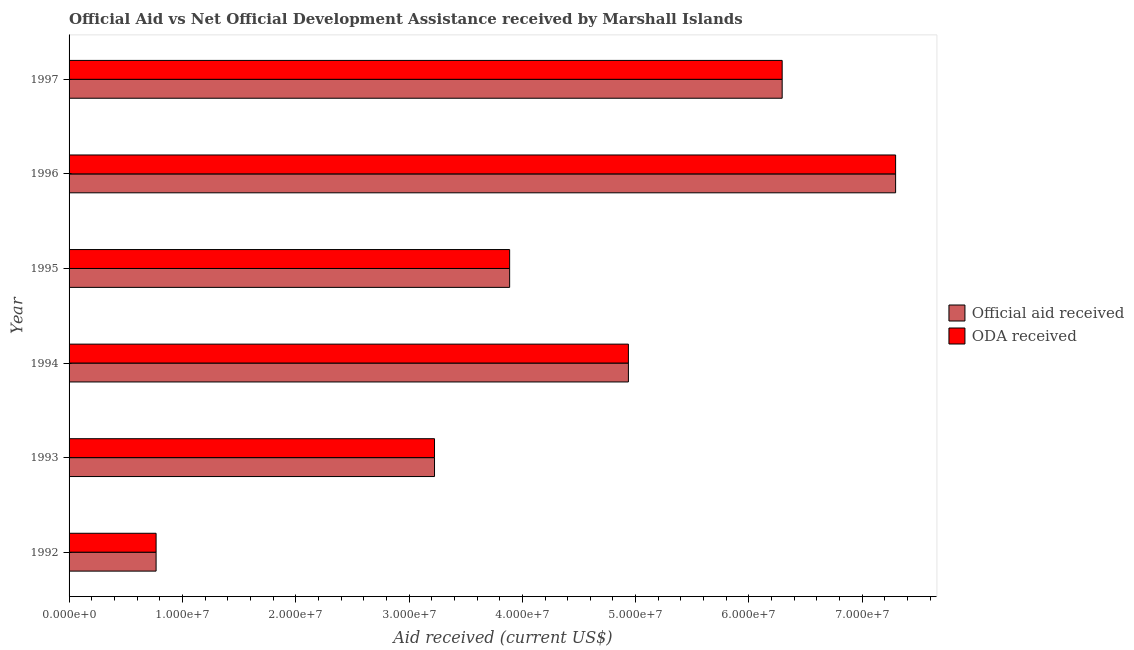How many different coloured bars are there?
Make the answer very short. 2. Are the number of bars per tick equal to the number of legend labels?
Make the answer very short. Yes. Are the number of bars on each tick of the Y-axis equal?
Offer a very short reply. Yes. How many bars are there on the 5th tick from the top?
Give a very brief answer. 2. How many bars are there on the 4th tick from the bottom?
Provide a short and direct response. 2. What is the oda received in 1997?
Ensure brevity in your answer.  6.29e+07. Across all years, what is the maximum official aid received?
Your answer should be very brief. 7.29e+07. Across all years, what is the minimum oda received?
Your answer should be compact. 7.68e+06. In which year was the official aid received maximum?
Your answer should be compact. 1996. In which year was the official aid received minimum?
Give a very brief answer. 1992. What is the total oda received in the graph?
Your answer should be very brief. 2.64e+08. What is the difference between the oda received in 1993 and that in 1994?
Offer a terse response. -1.71e+07. What is the difference between the oda received in 1995 and the official aid received in 1994?
Keep it short and to the point. -1.05e+07. What is the average official aid received per year?
Give a very brief answer. 4.40e+07. In the year 1996, what is the difference between the official aid received and oda received?
Your answer should be very brief. 0. What is the ratio of the oda received in 1992 to that in 1994?
Offer a terse response. 0.16. Is the difference between the oda received in 1992 and 1996 greater than the difference between the official aid received in 1992 and 1996?
Provide a short and direct response. No. What is the difference between the highest and the second highest official aid received?
Offer a very short reply. 1.00e+07. What is the difference between the highest and the lowest official aid received?
Provide a succinct answer. 6.53e+07. Is the sum of the official aid received in 1992 and 1995 greater than the maximum oda received across all years?
Offer a very short reply. No. What does the 1st bar from the top in 1995 represents?
Your answer should be compact. ODA received. What does the 1st bar from the bottom in 1995 represents?
Give a very brief answer. Official aid received. What is the difference between two consecutive major ticks on the X-axis?
Your response must be concise. 1.00e+07. Are the values on the major ticks of X-axis written in scientific E-notation?
Your answer should be compact. Yes. Does the graph contain grids?
Ensure brevity in your answer.  No. Where does the legend appear in the graph?
Offer a terse response. Center right. How are the legend labels stacked?
Keep it short and to the point. Vertical. What is the title of the graph?
Offer a very short reply. Official Aid vs Net Official Development Assistance received by Marshall Islands . Does "RDB nonconcessional" appear as one of the legend labels in the graph?
Provide a short and direct response. No. What is the label or title of the X-axis?
Your response must be concise. Aid received (current US$). What is the Aid received (current US$) in Official aid received in 1992?
Your answer should be compact. 7.68e+06. What is the Aid received (current US$) in ODA received in 1992?
Give a very brief answer. 7.68e+06. What is the Aid received (current US$) of Official aid received in 1993?
Offer a very short reply. 3.22e+07. What is the Aid received (current US$) of ODA received in 1993?
Offer a very short reply. 3.22e+07. What is the Aid received (current US$) in Official aid received in 1994?
Your response must be concise. 4.94e+07. What is the Aid received (current US$) in ODA received in 1994?
Your response must be concise. 4.94e+07. What is the Aid received (current US$) in Official aid received in 1995?
Give a very brief answer. 3.89e+07. What is the Aid received (current US$) of ODA received in 1995?
Provide a short and direct response. 3.89e+07. What is the Aid received (current US$) of Official aid received in 1996?
Your answer should be compact. 7.29e+07. What is the Aid received (current US$) of ODA received in 1996?
Your answer should be very brief. 7.29e+07. What is the Aid received (current US$) of Official aid received in 1997?
Provide a succinct answer. 6.29e+07. What is the Aid received (current US$) of ODA received in 1997?
Your answer should be very brief. 6.29e+07. Across all years, what is the maximum Aid received (current US$) of Official aid received?
Your answer should be compact. 7.29e+07. Across all years, what is the maximum Aid received (current US$) of ODA received?
Offer a terse response. 7.29e+07. Across all years, what is the minimum Aid received (current US$) in Official aid received?
Give a very brief answer. 7.68e+06. Across all years, what is the minimum Aid received (current US$) in ODA received?
Your answer should be very brief. 7.68e+06. What is the total Aid received (current US$) in Official aid received in the graph?
Offer a terse response. 2.64e+08. What is the total Aid received (current US$) in ODA received in the graph?
Your answer should be very brief. 2.64e+08. What is the difference between the Aid received (current US$) of Official aid received in 1992 and that in 1993?
Ensure brevity in your answer.  -2.46e+07. What is the difference between the Aid received (current US$) of ODA received in 1992 and that in 1993?
Ensure brevity in your answer.  -2.46e+07. What is the difference between the Aid received (current US$) of Official aid received in 1992 and that in 1994?
Keep it short and to the point. -4.17e+07. What is the difference between the Aid received (current US$) in ODA received in 1992 and that in 1994?
Provide a short and direct response. -4.17e+07. What is the difference between the Aid received (current US$) in Official aid received in 1992 and that in 1995?
Offer a terse response. -3.12e+07. What is the difference between the Aid received (current US$) in ODA received in 1992 and that in 1995?
Ensure brevity in your answer.  -3.12e+07. What is the difference between the Aid received (current US$) in Official aid received in 1992 and that in 1996?
Offer a terse response. -6.53e+07. What is the difference between the Aid received (current US$) in ODA received in 1992 and that in 1996?
Offer a terse response. -6.53e+07. What is the difference between the Aid received (current US$) of Official aid received in 1992 and that in 1997?
Your answer should be very brief. -5.52e+07. What is the difference between the Aid received (current US$) in ODA received in 1992 and that in 1997?
Provide a succinct answer. -5.52e+07. What is the difference between the Aid received (current US$) in Official aid received in 1993 and that in 1994?
Keep it short and to the point. -1.71e+07. What is the difference between the Aid received (current US$) in ODA received in 1993 and that in 1994?
Your answer should be very brief. -1.71e+07. What is the difference between the Aid received (current US$) in Official aid received in 1993 and that in 1995?
Offer a very short reply. -6.63e+06. What is the difference between the Aid received (current US$) of ODA received in 1993 and that in 1995?
Make the answer very short. -6.63e+06. What is the difference between the Aid received (current US$) of Official aid received in 1993 and that in 1996?
Your answer should be compact. -4.07e+07. What is the difference between the Aid received (current US$) of ODA received in 1993 and that in 1996?
Ensure brevity in your answer.  -4.07e+07. What is the difference between the Aid received (current US$) of Official aid received in 1993 and that in 1997?
Give a very brief answer. -3.07e+07. What is the difference between the Aid received (current US$) in ODA received in 1993 and that in 1997?
Keep it short and to the point. -3.07e+07. What is the difference between the Aid received (current US$) in Official aid received in 1994 and that in 1995?
Your answer should be compact. 1.05e+07. What is the difference between the Aid received (current US$) in ODA received in 1994 and that in 1995?
Provide a succinct answer. 1.05e+07. What is the difference between the Aid received (current US$) in Official aid received in 1994 and that in 1996?
Give a very brief answer. -2.36e+07. What is the difference between the Aid received (current US$) of ODA received in 1994 and that in 1996?
Make the answer very short. -2.36e+07. What is the difference between the Aid received (current US$) of Official aid received in 1994 and that in 1997?
Offer a terse response. -1.36e+07. What is the difference between the Aid received (current US$) in ODA received in 1994 and that in 1997?
Offer a terse response. -1.36e+07. What is the difference between the Aid received (current US$) in Official aid received in 1995 and that in 1996?
Offer a very short reply. -3.41e+07. What is the difference between the Aid received (current US$) of ODA received in 1995 and that in 1996?
Ensure brevity in your answer.  -3.41e+07. What is the difference between the Aid received (current US$) of Official aid received in 1995 and that in 1997?
Your answer should be very brief. -2.40e+07. What is the difference between the Aid received (current US$) of ODA received in 1995 and that in 1997?
Your answer should be very brief. -2.40e+07. What is the difference between the Aid received (current US$) in Official aid received in 1996 and that in 1997?
Provide a short and direct response. 1.00e+07. What is the difference between the Aid received (current US$) of ODA received in 1996 and that in 1997?
Provide a succinct answer. 1.00e+07. What is the difference between the Aid received (current US$) of Official aid received in 1992 and the Aid received (current US$) of ODA received in 1993?
Offer a terse response. -2.46e+07. What is the difference between the Aid received (current US$) of Official aid received in 1992 and the Aid received (current US$) of ODA received in 1994?
Provide a succinct answer. -4.17e+07. What is the difference between the Aid received (current US$) of Official aid received in 1992 and the Aid received (current US$) of ODA received in 1995?
Keep it short and to the point. -3.12e+07. What is the difference between the Aid received (current US$) in Official aid received in 1992 and the Aid received (current US$) in ODA received in 1996?
Your answer should be compact. -6.53e+07. What is the difference between the Aid received (current US$) in Official aid received in 1992 and the Aid received (current US$) in ODA received in 1997?
Your answer should be very brief. -5.52e+07. What is the difference between the Aid received (current US$) of Official aid received in 1993 and the Aid received (current US$) of ODA received in 1994?
Ensure brevity in your answer.  -1.71e+07. What is the difference between the Aid received (current US$) in Official aid received in 1993 and the Aid received (current US$) in ODA received in 1995?
Make the answer very short. -6.63e+06. What is the difference between the Aid received (current US$) in Official aid received in 1993 and the Aid received (current US$) in ODA received in 1996?
Provide a succinct answer. -4.07e+07. What is the difference between the Aid received (current US$) of Official aid received in 1993 and the Aid received (current US$) of ODA received in 1997?
Ensure brevity in your answer.  -3.07e+07. What is the difference between the Aid received (current US$) of Official aid received in 1994 and the Aid received (current US$) of ODA received in 1995?
Your response must be concise. 1.05e+07. What is the difference between the Aid received (current US$) of Official aid received in 1994 and the Aid received (current US$) of ODA received in 1996?
Give a very brief answer. -2.36e+07. What is the difference between the Aid received (current US$) of Official aid received in 1994 and the Aid received (current US$) of ODA received in 1997?
Your response must be concise. -1.36e+07. What is the difference between the Aid received (current US$) in Official aid received in 1995 and the Aid received (current US$) in ODA received in 1996?
Keep it short and to the point. -3.41e+07. What is the difference between the Aid received (current US$) of Official aid received in 1995 and the Aid received (current US$) of ODA received in 1997?
Your answer should be very brief. -2.40e+07. What is the difference between the Aid received (current US$) in Official aid received in 1996 and the Aid received (current US$) in ODA received in 1997?
Keep it short and to the point. 1.00e+07. What is the average Aid received (current US$) of Official aid received per year?
Provide a succinct answer. 4.40e+07. What is the average Aid received (current US$) in ODA received per year?
Provide a short and direct response. 4.40e+07. In the year 1996, what is the difference between the Aid received (current US$) of Official aid received and Aid received (current US$) of ODA received?
Provide a succinct answer. 0. In the year 1997, what is the difference between the Aid received (current US$) in Official aid received and Aid received (current US$) in ODA received?
Keep it short and to the point. 0. What is the ratio of the Aid received (current US$) of Official aid received in 1992 to that in 1993?
Offer a terse response. 0.24. What is the ratio of the Aid received (current US$) of ODA received in 1992 to that in 1993?
Offer a very short reply. 0.24. What is the ratio of the Aid received (current US$) in Official aid received in 1992 to that in 1994?
Ensure brevity in your answer.  0.16. What is the ratio of the Aid received (current US$) in ODA received in 1992 to that in 1994?
Keep it short and to the point. 0.16. What is the ratio of the Aid received (current US$) in Official aid received in 1992 to that in 1995?
Your response must be concise. 0.2. What is the ratio of the Aid received (current US$) of ODA received in 1992 to that in 1995?
Provide a short and direct response. 0.2. What is the ratio of the Aid received (current US$) in Official aid received in 1992 to that in 1996?
Offer a terse response. 0.11. What is the ratio of the Aid received (current US$) in ODA received in 1992 to that in 1996?
Make the answer very short. 0.11. What is the ratio of the Aid received (current US$) in Official aid received in 1992 to that in 1997?
Provide a short and direct response. 0.12. What is the ratio of the Aid received (current US$) in ODA received in 1992 to that in 1997?
Ensure brevity in your answer.  0.12. What is the ratio of the Aid received (current US$) of Official aid received in 1993 to that in 1994?
Keep it short and to the point. 0.65. What is the ratio of the Aid received (current US$) of ODA received in 1993 to that in 1994?
Provide a short and direct response. 0.65. What is the ratio of the Aid received (current US$) in Official aid received in 1993 to that in 1995?
Your answer should be very brief. 0.83. What is the ratio of the Aid received (current US$) in ODA received in 1993 to that in 1995?
Make the answer very short. 0.83. What is the ratio of the Aid received (current US$) of Official aid received in 1993 to that in 1996?
Provide a short and direct response. 0.44. What is the ratio of the Aid received (current US$) in ODA received in 1993 to that in 1996?
Your response must be concise. 0.44. What is the ratio of the Aid received (current US$) in Official aid received in 1993 to that in 1997?
Your answer should be very brief. 0.51. What is the ratio of the Aid received (current US$) in ODA received in 1993 to that in 1997?
Provide a short and direct response. 0.51. What is the ratio of the Aid received (current US$) in Official aid received in 1994 to that in 1995?
Offer a very short reply. 1.27. What is the ratio of the Aid received (current US$) of ODA received in 1994 to that in 1995?
Make the answer very short. 1.27. What is the ratio of the Aid received (current US$) in Official aid received in 1994 to that in 1996?
Offer a very short reply. 0.68. What is the ratio of the Aid received (current US$) in ODA received in 1994 to that in 1996?
Your response must be concise. 0.68. What is the ratio of the Aid received (current US$) of Official aid received in 1994 to that in 1997?
Provide a succinct answer. 0.78. What is the ratio of the Aid received (current US$) of ODA received in 1994 to that in 1997?
Offer a terse response. 0.78. What is the ratio of the Aid received (current US$) in Official aid received in 1995 to that in 1996?
Your answer should be very brief. 0.53. What is the ratio of the Aid received (current US$) in ODA received in 1995 to that in 1996?
Offer a terse response. 0.53. What is the ratio of the Aid received (current US$) of Official aid received in 1995 to that in 1997?
Offer a very short reply. 0.62. What is the ratio of the Aid received (current US$) in ODA received in 1995 to that in 1997?
Your answer should be compact. 0.62. What is the ratio of the Aid received (current US$) in Official aid received in 1996 to that in 1997?
Provide a short and direct response. 1.16. What is the ratio of the Aid received (current US$) of ODA received in 1996 to that in 1997?
Your answer should be compact. 1.16. What is the difference between the highest and the second highest Aid received (current US$) of Official aid received?
Offer a terse response. 1.00e+07. What is the difference between the highest and the second highest Aid received (current US$) in ODA received?
Provide a succinct answer. 1.00e+07. What is the difference between the highest and the lowest Aid received (current US$) in Official aid received?
Provide a short and direct response. 6.53e+07. What is the difference between the highest and the lowest Aid received (current US$) of ODA received?
Your answer should be compact. 6.53e+07. 